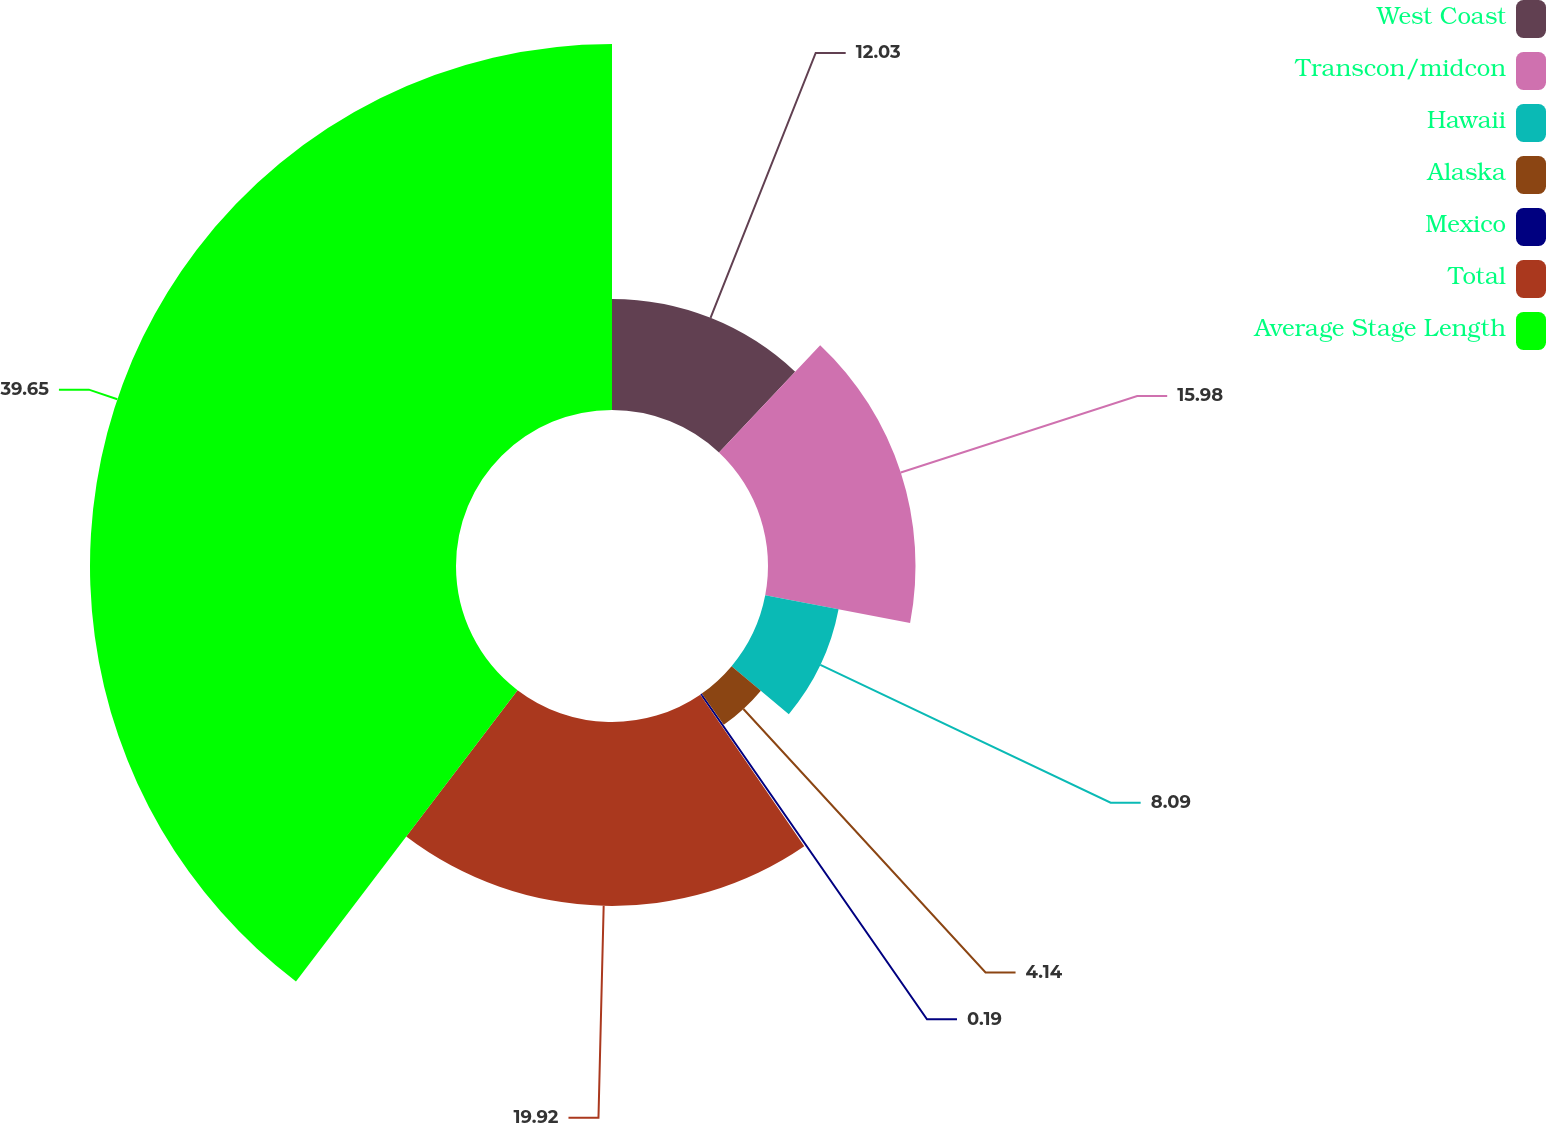<chart> <loc_0><loc_0><loc_500><loc_500><pie_chart><fcel>West Coast<fcel>Transcon/midcon<fcel>Hawaii<fcel>Alaska<fcel>Mexico<fcel>Total<fcel>Average Stage Length<nl><fcel>12.03%<fcel>15.98%<fcel>8.09%<fcel>4.14%<fcel>0.19%<fcel>19.92%<fcel>39.65%<nl></chart> 